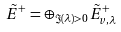Convert formula to latex. <formula><loc_0><loc_0><loc_500><loc_500>\tilde { E } ^ { + } = \oplus _ { \Im ( \lambda ) > 0 } \tilde { E } _ { v , \lambda } ^ { + }</formula> 